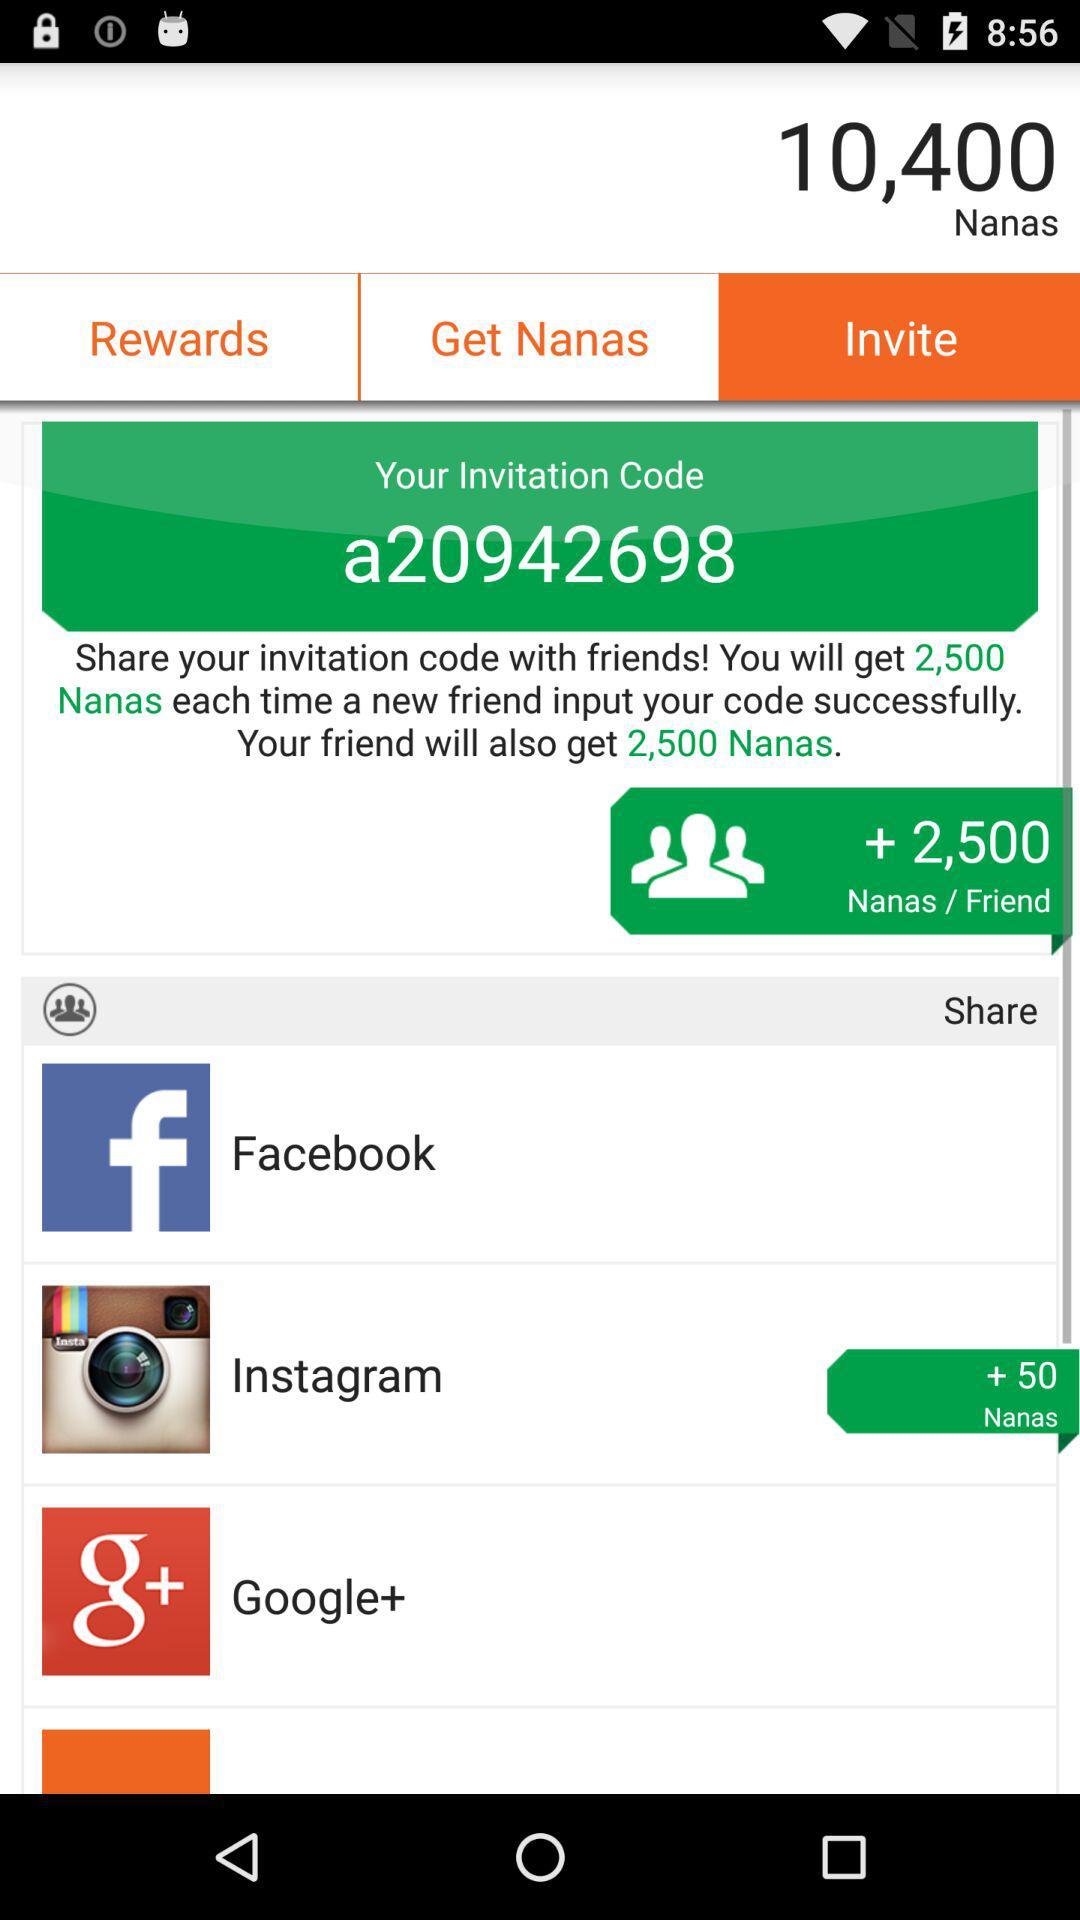How many Nanas does the user have?
Answer the question using a single word or phrase. 10,400 